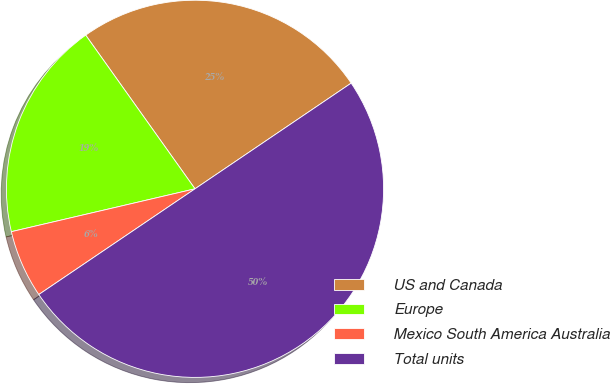<chart> <loc_0><loc_0><loc_500><loc_500><pie_chart><fcel>US and Canada<fcel>Europe<fcel>Mexico South America Australia<fcel>Total units<nl><fcel>25.37%<fcel>18.81%<fcel>5.82%<fcel>50.0%<nl></chart> 